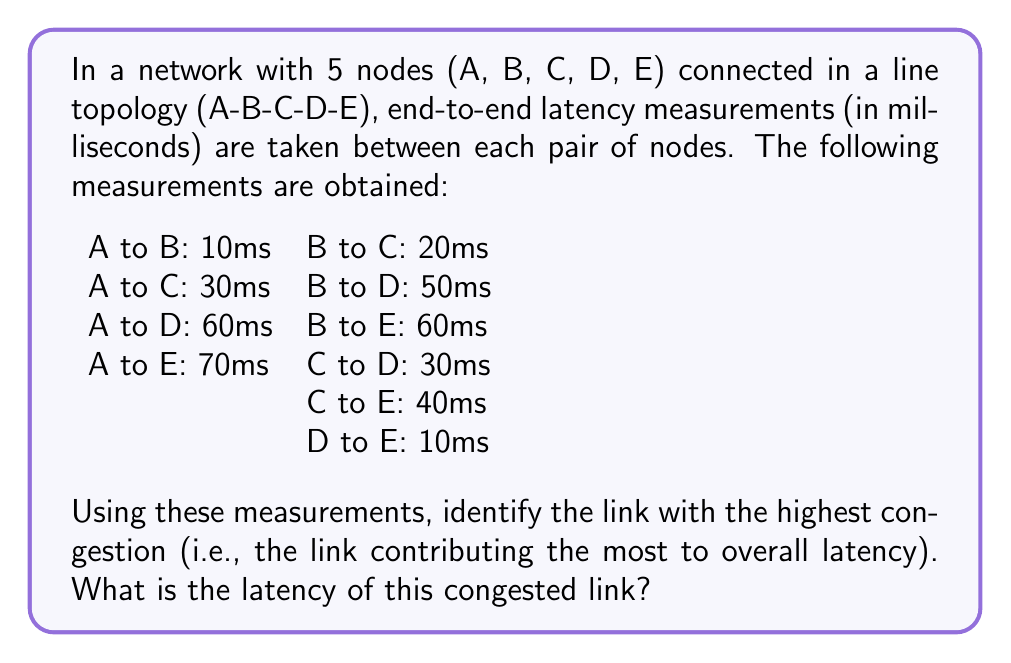What is the answer to this math problem? To solve this inverse problem and identify the most congested link, we need to infer the individual link latencies from the end-to-end measurements. Let's approach this step-by-step:

1) Let's denote the latency of each link as follows:
   $L_{AB}$: latency between A and B
   $L_{BC}$: latency between B and C
   $L_{CD}$: latency between C and D
   $L_{DE}$: latency between D and E

2) We can set up a system of equations based on the measurements:

   $$\begin{align}
   L_{AB} &= 10 \\
   L_{AB} + L_{BC} &= 30 \\
   L_{AB} + L_{BC} + L_{CD} &= 60 \\
   L_{AB} + L_{BC} + L_{CD} + L_{DE} &= 70 \\
   L_{BC} &= 20 \\
   L_{BC} + L_{CD} &= 50 \\
   L_{BC} + L_{CD} + L_{DE} &= 60 \\
   L_{CD} &= 30 \\
   L_{CD} + L_{DE} &= 40 \\
   L_{DE} &= 10
   \end{align}$$

3) From these equations, we can directly determine:
   $L_{AB} = 10$ ms
   $L_{BC} = 20$ ms
   $L_{CD} = 30$ ms
   $L_{DE} = 10$ ms

4) We can verify these results using the other equations:
   $L_{AB} + L_{BC} = 10 + 20 = 30$ ms (matches A to C)
   $L_{AB} + L_{BC} + L_{CD} = 10 + 20 + 30 = 60$ ms (matches A to D)
   $L_{AB} + L_{BC} + L_{CD} + L_{DE} = 10 + 20 + 30 + 10 = 70$ ms (matches A to E)

5) Comparing the latencies of all links:
   $L_{AB} = 10$ ms
   $L_{BC} = 20$ ms
   $L_{CD} = 30$ ms
   $L_{DE} = 10$ ms

6) The link with the highest latency, and thus the most congestion, is the link between C and D with a latency of 30 ms.
Answer: 30 ms 